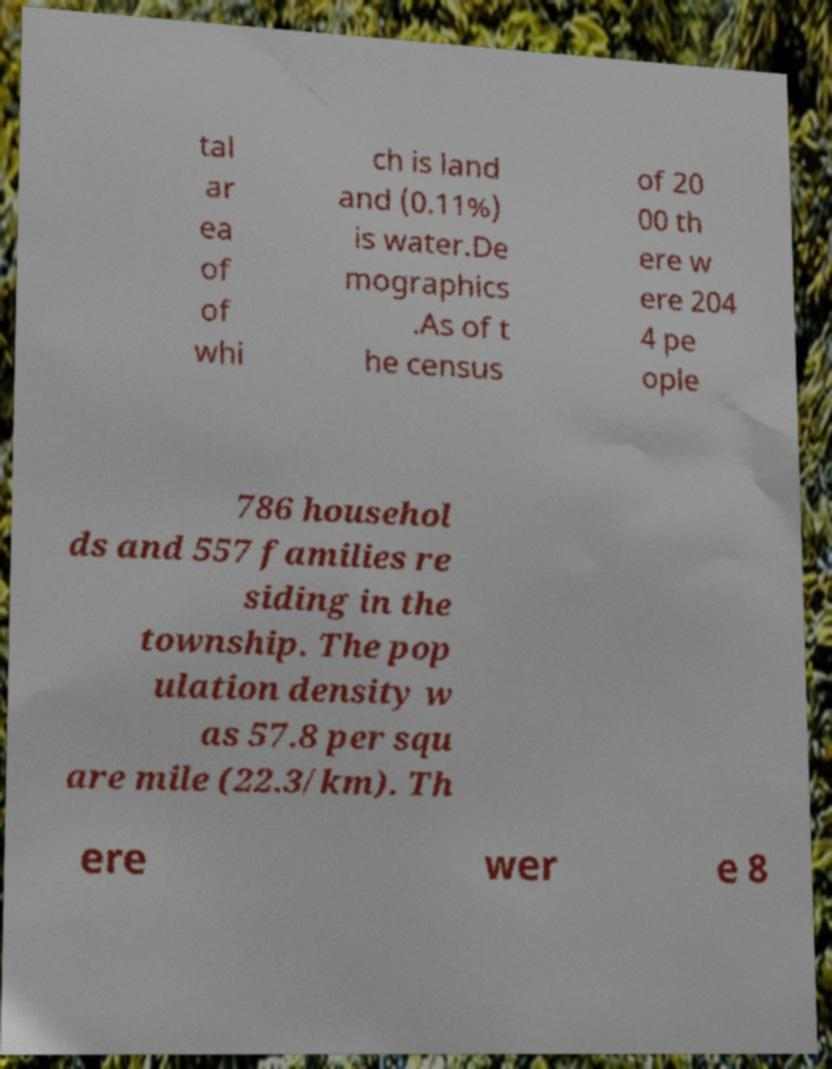Can you accurately transcribe the text from the provided image for me? tal ar ea of of whi ch is land and (0.11%) is water.De mographics .As of t he census of 20 00 th ere w ere 204 4 pe ople 786 househol ds and 557 families re siding in the township. The pop ulation density w as 57.8 per squ are mile (22.3/km). Th ere wer e 8 